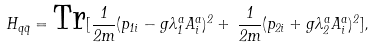<formula> <loc_0><loc_0><loc_500><loc_500>H _ { q \bar { q } } = \text {Tr} [ \frac { 1 } { 2 m } ( p _ { 1 i } - g \lambda ^ { a } _ { 1 } A ^ { a } _ { i } ) ^ { 2 } + \, \frac { 1 } { 2 m } ( p _ { 2 i } + g \lambda ^ { a } _ { 2 } A ^ { a } _ { i } ) ^ { 2 } ] ,</formula> 